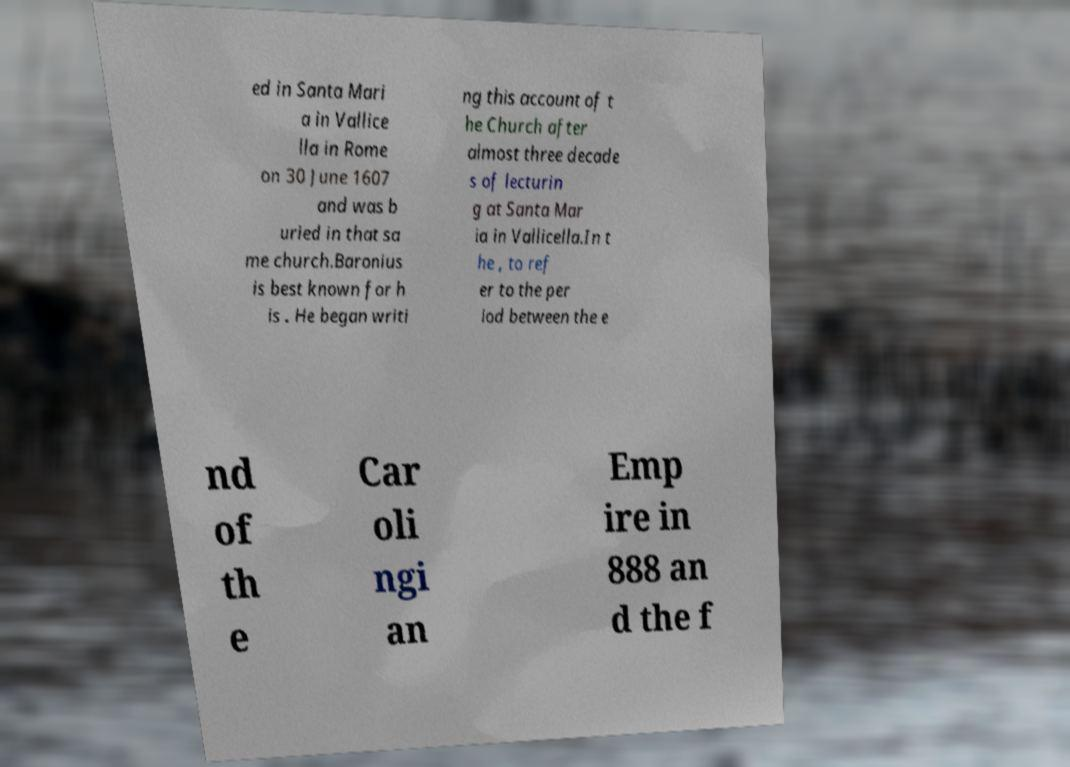Could you extract and type out the text from this image? ed in Santa Mari a in Vallice lla in Rome on 30 June 1607 and was b uried in that sa me church.Baronius is best known for h is . He began writi ng this account of t he Church after almost three decade s of lecturin g at Santa Mar ia in Vallicella.In t he , to ref er to the per iod between the e nd of th e Car oli ngi an Emp ire in 888 an d the f 